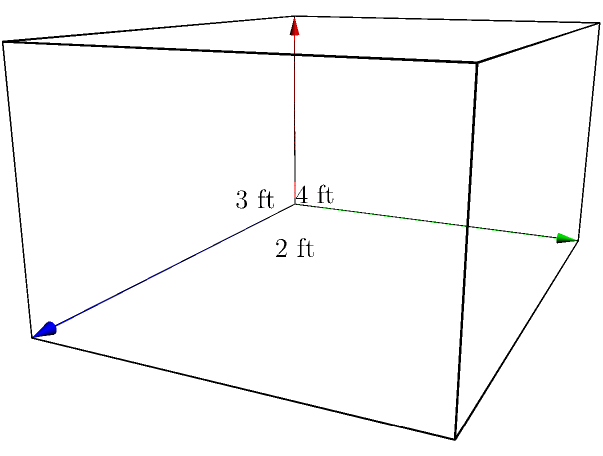A local food bank is organizing a donation drive for families in need. They want to use rectangular boxes to pack and distribute the donated items. The dimensions of each box are 4 feet in length, 3 feet in width, and 2 feet in height. As a volunteer, you need to calculate the volume of each box to determine how much food it can hold. What is the volume of one donation box in cubic feet? To find the volume of a rectangular box, we need to multiply its length, width, and height. Let's follow these steps:

1. Identify the dimensions:
   - Length = 4 feet
   - Width = 3 feet
   - Height = 2 feet

2. Apply the formula for the volume of a rectangular prism:
   $$ V = l \times w \times h $$
   Where:
   $V$ = volume
   $l$ = length
   $w$ = width
   $h$ = height

3. Substitute the values into the formula:
   $$ V = 4 \text{ ft} \times 3 \text{ ft} \times 2 \text{ ft} $$

4. Multiply the numbers:
   $$ V = 24 \text{ ft}^3 $$

Therefore, the volume of one donation box is 24 cubic feet.
Answer: $24 \text{ ft}^3$ 